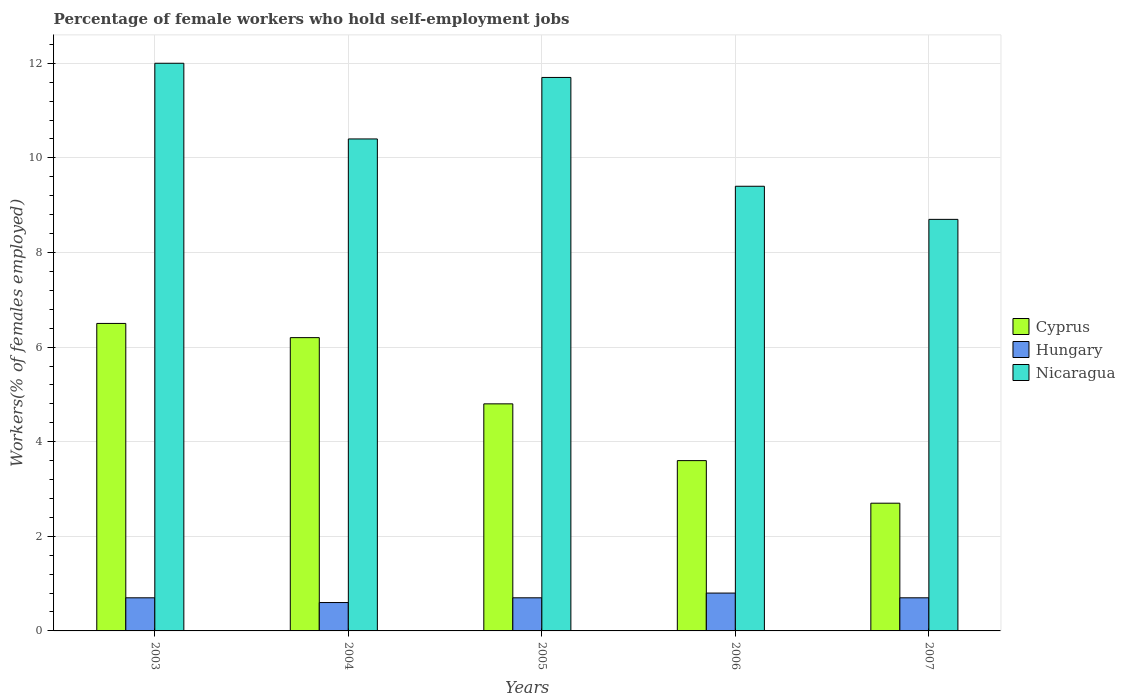How many different coloured bars are there?
Ensure brevity in your answer.  3. Are the number of bars per tick equal to the number of legend labels?
Your answer should be compact. Yes. How many bars are there on the 4th tick from the left?
Your answer should be compact. 3. How many bars are there on the 4th tick from the right?
Your answer should be compact. 3. What is the label of the 4th group of bars from the left?
Your answer should be very brief. 2006. In how many cases, is the number of bars for a given year not equal to the number of legend labels?
Your response must be concise. 0. What is the percentage of self-employed female workers in Cyprus in 2007?
Offer a terse response. 2.7. Across all years, what is the minimum percentage of self-employed female workers in Nicaragua?
Offer a very short reply. 8.7. In which year was the percentage of self-employed female workers in Nicaragua minimum?
Ensure brevity in your answer.  2007. What is the total percentage of self-employed female workers in Cyprus in the graph?
Keep it short and to the point. 23.8. What is the difference between the percentage of self-employed female workers in Nicaragua in 2003 and that in 2004?
Your answer should be compact. 1.6. What is the difference between the percentage of self-employed female workers in Cyprus in 2003 and the percentage of self-employed female workers in Nicaragua in 2006?
Give a very brief answer. -2.9. What is the average percentage of self-employed female workers in Nicaragua per year?
Offer a very short reply. 10.44. In the year 2006, what is the difference between the percentage of self-employed female workers in Nicaragua and percentage of self-employed female workers in Hungary?
Your answer should be very brief. 8.6. In how many years, is the percentage of self-employed female workers in Cyprus greater than 1.2000000000000002 %?
Offer a terse response. 5. What is the ratio of the percentage of self-employed female workers in Nicaragua in 2003 to that in 2007?
Provide a short and direct response. 1.38. What is the difference between the highest and the second highest percentage of self-employed female workers in Cyprus?
Your answer should be very brief. 0.3. What is the difference between the highest and the lowest percentage of self-employed female workers in Hungary?
Make the answer very short. 0.2. In how many years, is the percentage of self-employed female workers in Cyprus greater than the average percentage of self-employed female workers in Cyprus taken over all years?
Make the answer very short. 3. What does the 2nd bar from the left in 2004 represents?
Your answer should be very brief. Hungary. What does the 3rd bar from the right in 2003 represents?
Your answer should be very brief. Cyprus. Is it the case that in every year, the sum of the percentage of self-employed female workers in Cyprus and percentage of self-employed female workers in Nicaragua is greater than the percentage of self-employed female workers in Hungary?
Your answer should be compact. Yes. How many bars are there?
Offer a very short reply. 15. What is the difference between two consecutive major ticks on the Y-axis?
Keep it short and to the point. 2. Does the graph contain any zero values?
Keep it short and to the point. No. How many legend labels are there?
Provide a succinct answer. 3. How are the legend labels stacked?
Make the answer very short. Vertical. What is the title of the graph?
Give a very brief answer. Percentage of female workers who hold self-employment jobs. Does "Papua New Guinea" appear as one of the legend labels in the graph?
Keep it short and to the point. No. What is the label or title of the X-axis?
Your answer should be compact. Years. What is the label or title of the Y-axis?
Offer a very short reply. Workers(% of females employed). What is the Workers(% of females employed) of Cyprus in 2003?
Offer a terse response. 6.5. What is the Workers(% of females employed) in Hungary in 2003?
Ensure brevity in your answer.  0.7. What is the Workers(% of females employed) of Nicaragua in 2003?
Ensure brevity in your answer.  12. What is the Workers(% of females employed) of Cyprus in 2004?
Offer a terse response. 6.2. What is the Workers(% of females employed) of Hungary in 2004?
Your response must be concise. 0.6. What is the Workers(% of females employed) in Nicaragua in 2004?
Keep it short and to the point. 10.4. What is the Workers(% of females employed) in Cyprus in 2005?
Keep it short and to the point. 4.8. What is the Workers(% of females employed) of Hungary in 2005?
Offer a very short reply. 0.7. What is the Workers(% of females employed) in Nicaragua in 2005?
Keep it short and to the point. 11.7. What is the Workers(% of females employed) of Cyprus in 2006?
Your answer should be very brief. 3.6. What is the Workers(% of females employed) in Hungary in 2006?
Provide a short and direct response. 0.8. What is the Workers(% of females employed) in Nicaragua in 2006?
Give a very brief answer. 9.4. What is the Workers(% of females employed) in Cyprus in 2007?
Ensure brevity in your answer.  2.7. What is the Workers(% of females employed) in Hungary in 2007?
Ensure brevity in your answer.  0.7. What is the Workers(% of females employed) of Nicaragua in 2007?
Provide a succinct answer. 8.7. Across all years, what is the maximum Workers(% of females employed) in Hungary?
Offer a terse response. 0.8. Across all years, what is the minimum Workers(% of females employed) of Cyprus?
Give a very brief answer. 2.7. Across all years, what is the minimum Workers(% of females employed) in Hungary?
Your answer should be compact. 0.6. Across all years, what is the minimum Workers(% of females employed) of Nicaragua?
Ensure brevity in your answer.  8.7. What is the total Workers(% of females employed) in Cyprus in the graph?
Provide a succinct answer. 23.8. What is the total Workers(% of females employed) of Nicaragua in the graph?
Give a very brief answer. 52.2. What is the difference between the Workers(% of females employed) of Cyprus in 2003 and that in 2004?
Offer a terse response. 0.3. What is the difference between the Workers(% of females employed) of Cyprus in 2003 and that in 2005?
Offer a very short reply. 1.7. What is the difference between the Workers(% of females employed) of Cyprus in 2003 and that in 2006?
Ensure brevity in your answer.  2.9. What is the difference between the Workers(% of females employed) in Nicaragua in 2003 and that in 2006?
Provide a succinct answer. 2.6. What is the difference between the Workers(% of females employed) of Cyprus in 2003 and that in 2007?
Make the answer very short. 3.8. What is the difference between the Workers(% of females employed) in Hungary in 2003 and that in 2007?
Offer a terse response. 0. What is the difference between the Workers(% of females employed) in Nicaragua in 2003 and that in 2007?
Your answer should be compact. 3.3. What is the difference between the Workers(% of females employed) of Cyprus in 2004 and that in 2005?
Offer a very short reply. 1.4. What is the difference between the Workers(% of females employed) in Hungary in 2004 and that in 2005?
Ensure brevity in your answer.  -0.1. What is the difference between the Workers(% of females employed) of Nicaragua in 2004 and that in 2005?
Your answer should be compact. -1.3. What is the difference between the Workers(% of females employed) in Cyprus in 2004 and that in 2006?
Your response must be concise. 2.6. What is the difference between the Workers(% of females employed) in Nicaragua in 2004 and that in 2007?
Provide a succinct answer. 1.7. What is the difference between the Workers(% of females employed) in Cyprus in 2005 and that in 2006?
Your response must be concise. 1.2. What is the difference between the Workers(% of females employed) of Hungary in 2005 and that in 2006?
Offer a very short reply. -0.1. What is the difference between the Workers(% of females employed) of Nicaragua in 2005 and that in 2006?
Make the answer very short. 2.3. What is the difference between the Workers(% of females employed) in Hungary in 2005 and that in 2007?
Offer a very short reply. 0. What is the difference between the Workers(% of females employed) in Nicaragua in 2005 and that in 2007?
Make the answer very short. 3. What is the difference between the Workers(% of females employed) in Cyprus in 2006 and that in 2007?
Provide a succinct answer. 0.9. What is the difference between the Workers(% of females employed) in Hungary in 2006 and that in 2007?
Give a very brief answer. 0.1. What is the difference between the Workers(% of females employed) of Nicaragua in 2006 and that in 2007?
Ensure brevity in your answer.  0.7. What is the difference between the Workers(% of females employed) in Cyprus in 2003 and the Workers(% of females employed) in Hungary in 2004?
Provide a succinct answer. 5.9. What is the difference between the Workers(% of females employed) of Cyprus in 2003 and the Workers(% of females employed) of Nicaragua in 2004?
Offer a terse response. -3.9. What is the difference between the Workers(% of females employed) in Cyprus in 2003 and the Workers(% of females employed) in Nicaragua in 2005?
Offer a terse response. -5.2. What is the difference between the Workers(% of females employed) in Cyprus in 2003 and the Workers(% of females employed) in Nicaragua in 2006?
Your answer should be very brief. -2.9. What is the difference between the Workers(% of females employed) in Cyprus in 2003 and the Workers(% of females employed) in Hungary in 2007?
Ensure brevity in your answer.  5.8. What is the difference between the Workers(% of females employed) of Cyprus in 2003 and the Workers(% of females employed) of Nicaragua in 2007?
Your response must be concise. -2.2. What is the difference between the Workers(% of females employed) in Hungary in 2003 and the Workers(% of females employed) in Nicaragua in 2007?
Keep it short and to the point. -8. What is the difference between the Workers(% of females employed) of Hungary in 2004 and the Workers(% of females employed) of Nicaragua in 2005?
Offer a terse response. -11.1. What is the difference between the Workers(% of females employed) of Hungary in 2004 and the Workers(% of females employed) of Nicaragua in 2006?
Make the answer very short. -8.8. What is the difference between the Workers(% of females employed) in Cyprus in 2004 and the Workers(% of females employed) in Hungary in 2007?
Make the answer very short. 5.5. What is the difference between the Workers(% of females employed) in Hungary in 2004 and the Workers(% of females employed) in Nicaragua in 2007?
Provide a succinct answer. -8.1. What is the difference between the Workers(% of females employed) in Cyprus in 2005 and the Workers(% of females employed) in Hungary in 2006?
Keep it short and to the point. 4. What is the difference between the Workers(% of females employed) in Cyprus in 2005 and the Workers(% of females employed) in Nicaragua in 2006?
Ensure brevity in your answer.  -4.6. What is the difference between the Workers(% of females employed) of Hungary in 2005 and the Workers(% of females employed) of Nicaragua in 2006?
Give a very brief answer. -8.7. What is the difference between the Workers(% of females employed) of Cyprus in 2005 and the Workers(% of females employed) of Hungary in 2007?
Offer a very short reply. 4.1. What is the difference between the Workers(% of females employed) of Cyprus in 2005 and the Workers(% of females employed) of Nicaragua in 2007?
Offer a very short reply. -3.9. What is the average Workers(% of females employed) in Cyprus per year?
Your answer should be very brief. 4.76. What is the average Workers(% of females employed) of Nicaragua per year?
Your answer should be compact. 10.44. In the year 2003, what is the difference between the Workers(% of females employed) in Cyprus and Workers(% of females employed) in Hungary?
Offer a terse response. 5.8. In the year 2003, what is the difference between the Workers(% of females employed) in Cyprus and Workers(% of females employed) in Nicaragua?
Give a very brief answer. -5.5. In the year 2004, what is the difference between the Workers(% of females employed) in Cyprus and Workers(% of females employed) in Hungary?
Your answer should be very brief. 5.6. In the year 2005, what is the difference between the Workers(% of females employed) in Cyprus and Workers(% of females employed) in Nicaragua?
Provide a short and direct response. -6.9. In the year 2005, what is the difference between the Workers(% of females employed) of Hungary and Workers(% of females employed) of Nicaragua?
Offer a very short reply. -11. In the year 2006, what is the difference between the Workers(% of females employed) of Cyprus and Workers(% of females employed) of Hungary?
Make the answer very short. 2.8. In the year 2006, what is the difference between the Workers(% of females employed) in Cyprus and Workers(% of females employed) in Nicaragua?
Your answer should be very brief. -5.8. In the year 2007, what is the difference between the Workers(% of females employed) in Hungary and Workers(% of females employed) in Nicaragua?
Give a very brief answer. -8. What is the ratio of the Workers(% of females employed) in Cyprus in 2003 to that in 2004?
Offer a terse response. 1.05. What is the ratio of the Workers(% of females employed) of Hungary in 2003 to that in 2004?
Offer a very short reply. 1.17. What is the ratio of the Workers(% of females employed) of Nicaragua in 2003 to that in 2004?
Offer a very short reply. 1.15. What is the ratio of the Workers(% of females employed) of Cyprus in 2003 to that in 2005?
Your response must be concise. 1.35. What is the ratio of the Workers(% of females employed) in Hungary in 2003 to that in 2005?
Provide a short and direct response. 1. What is the ratio of the Workers(% of females employed) in Nicaragua in 2003 to that in 2005?
Offer a terse response. 1.03. What is the ratio of the Workers(% of females employed) in Cyprus in 2003 to that in 2006?
Your response must be concise. 1.81. What is the ratio of the Workers(% of females employed) of Hungary in 2003 to that in 2006?
Offer a very short reply. 0.88. What is the ratio of the Workers(% of females employed) in Nicaragua in 2003 to that in 2006?
Your answer should be compact. 1.28. What is the ratio of the Workers(% of females employed) of Cyprus in 2003 to that in 2007?
Provide a short and direct response. 2.41. What is the ratio of the Workers(% of females employed) of Hungary in 2003 to that in 2007?
Your answer should be very brief. 1. What is the ratio of the Workers(% of females employed) in Nicaragua in 2003 to that in 2007?
Provide a succinct answer. 1.38. What is the ratio of the Workers(% of females employed) of Cyprus in 2004 to that in 2005?
Provide a short and direct response. 1.29. What is the ratio of the Workers(% of females employed) of Hungary in 2004 to that in 2005?
Provide a short and direct response. 0.86. What is the ratio of the Workers(% of females employed) in Nicaragua in 2004 to that in 2005?
Your answer should be very brief. 0.89. What is the ratio of the Workers(% of females employed) in Cyprus in 2004 to that in 2006?
Keep it short and to the point. 1.72. What is the ratio of the Workers(% of females employed) in Nicaragua in 2004 to that in 2006?
Provide a succinct answer. 1.11. What is the ratio of the Workers(% of females employed) in Cyprus in 2004 to that in 2007?
Offer a terse response. 2.3. What is the ratio of the Workers(% of females employed) in Hungary in 2004 to that in 2007?
Ensure brevity in your answer.  0.86. What is the ratio of the Workers(% of females employed) in Nicaragua in 2004 to that in 2007?
Give a very brief answer. 1.2. What is the ratio of the Workers(% of females employed) in Cyprus in 2005 to that in 2006?
Your answer should be compact. 1.33. What is the ratio of the Workers(% of females employed) in Hungary in 2005 to that in 2006?
Give a very brief answer. 0.88. What is the ratio of the Workers(% of females employed) of Nicaragua in 2005 to that in 2006?
Make the answer very short. 1.24. What is the ratio of the Workers(% of females employed) of Cyprus in 2005 to that in 2007?
Keep it short and to the point. 1.78. What is the ratio of the Workers(% of females employed) of Hungary in 2005 to that in 2007?
Keep it short and to the point. 1. What is the ratio of the Workers(% of females employed) of Nicaragua in 2005 to that in 2007?
Your answer should be compact. 1.34. What is the ratio of the Workers(% of females employed) in Nicaragua in 2006 to that in 2007?
Provide a succinct answer. 1.08. What is the difference between the highest and the second highest Workers(% of females employed) of Cyprus?
Give a very brief answer. 0.3. What is the difference between the highest and the second highest Workers(% of females employed) of Hungary?
Provide a short and direct response. 0.1. What is the difference between the highest and the second highest Workers(% of females employed) of Nicaragua?
Your answer should be very brief. 0.3. What is the difference between the highest and the lowest Workers(% of females employed) of Cyprus?
Give a very brief answer. 3.8. What is the difference between the highest and the lowest Workers(% of females employed) of Nicaragua?
Make the answer very short. 3.3. 